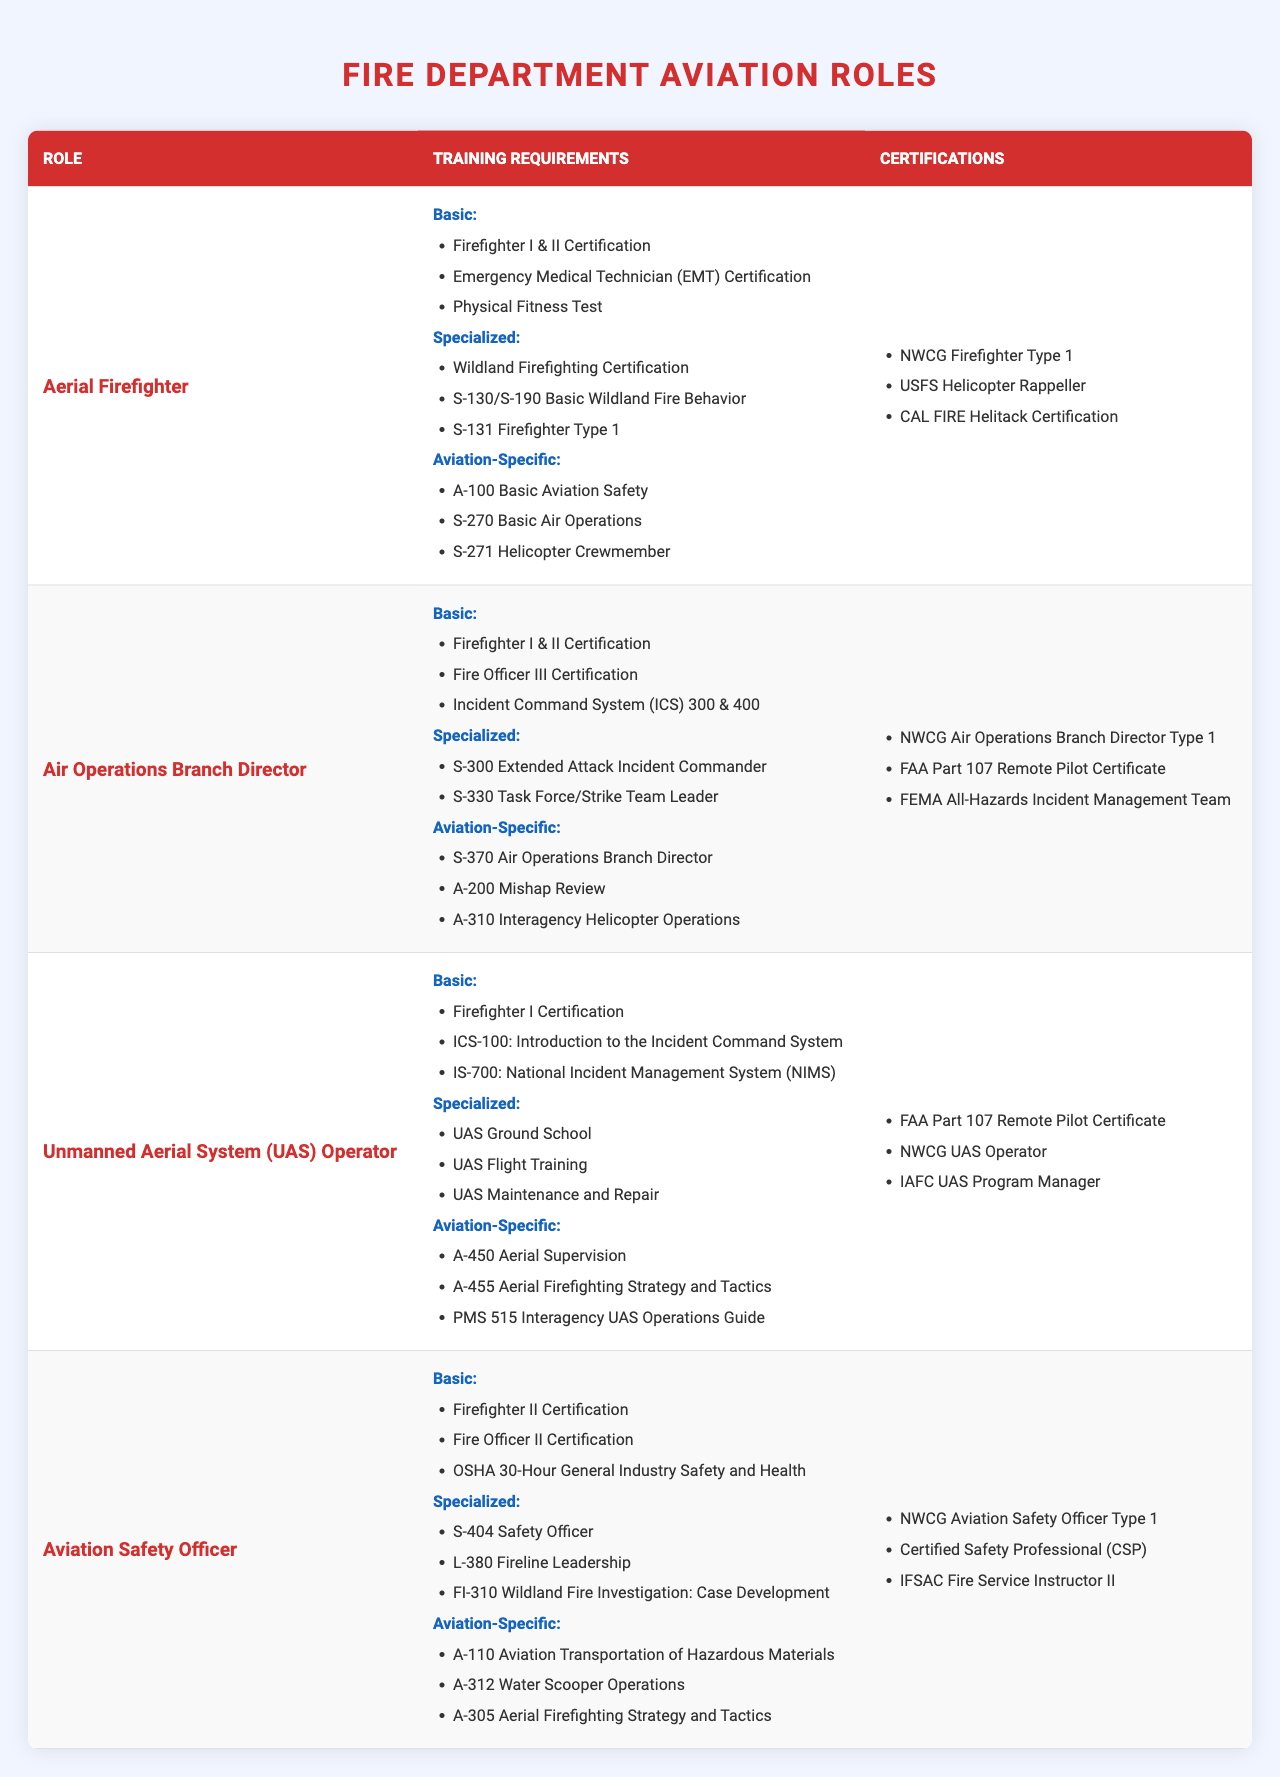What are the training requirements for an Aerial Firefighter? The training requirements for an Aerial Firefighter are divided into three categories: Basic, Specialized, and Aviation-Specific. Under Basic, they include Firefighter I & II Certification, EMT Certification, and Physical Fitness Test. Specialized requirements include Wildland Firefighting Certification, S-130/S-190, and S-131. Aviation-Specific requirements are A-100, S-270, and S-271.
Answer: Firefighter I & II Certification, EMT Certification, Physical Fitness Test, Wildland Firefighting Certification, S-130/S-190, S-131, A-100, S-270, S-271 How many certifications does an Air Operations Branch Director need? An Air Operations Branch Director has three certifications listed: NWCG Air Operations Branch Director Type 1, FAA Part 107 Remote Pilot Certificate, and FEMA All-Hazards Incident Management Team.
Answer: Three certifications Is UAS Operator required to have Firefighter II Certification? The UAS Operator is required to have Firefighter I Certification only, which means they do not need Firefighter II Certification.
Answer: No Which role requires the training "S-404 Safety Officer"? The training "S-404 Safety Officer" is listed under the Aviation Safety Officer's specialized training requirements.
Answer: Aviation Safety Officer What is the total number of Basic training requirements for all roles combined? Each role has a different number of Basic training requirements: Aerial Firefighter (3), Air Operations Branch Director (3), UAS Operator (3), and Aviation Safety Officer (3). The total is 3 + 3 + 3 + 3 = 12.
Answer: 12 Do all of the aviation roles have the same number of required certifications? Aerial Firefighter has 3 certifications, Air Operations Branch Director has 3, UAS Operator has 3, and Aviation Safety Officer has 3. Since they all have the same number of certifications, the answer is yes.
Answer: Yes 